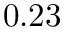<formula> <loc_0><loc_0><loc_500><loc_500>0 . 2 3</formula> 